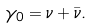Convert formula to latex. <formula><loc_0><loc_0><loc_500><loc_500>\gamma _ { 0 } = \nu + \bar { \nu } .</formula> 